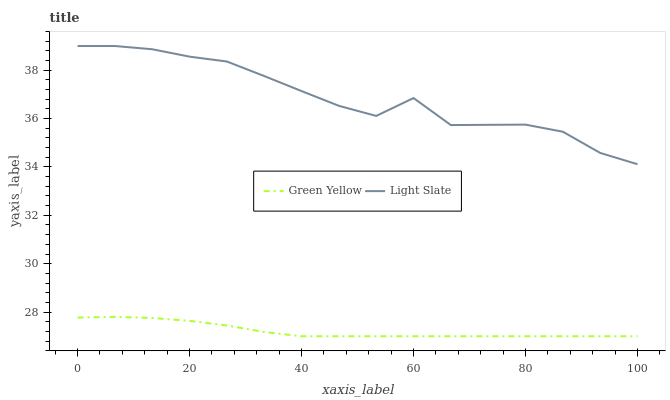Does Green Yellow have the minimum area under the curve?
Answer yes or no. Yes. Does Light Slate have the maximum area under the curve?
Answer yes or no. Yes. Does Green Yellow have the maximum area under the curve?
Answer yes or no. No. Is Green Yellow the smoothest?
Answer yes or no. Yes. Is Light Slate the roughest?
Answer yes or no. Yes. Is Green Yellow the roughest?
Answer yes or no. No. Does Green Yellow have the lowest value?
Answer yes or no. Yes. Does Light Slate have the highest value?
Answer yes or no. Yes. Does Green Yellow have the highest value?
Answer yes or no. No. Is Green Yellow less than Light Slate?
Answer yes or no. Yes. Is Light Slate greater than Green Yellow?
Answer yes or no. Yes. Does Green Yellow intersect Light Slate?
Answer yes or no. No. 